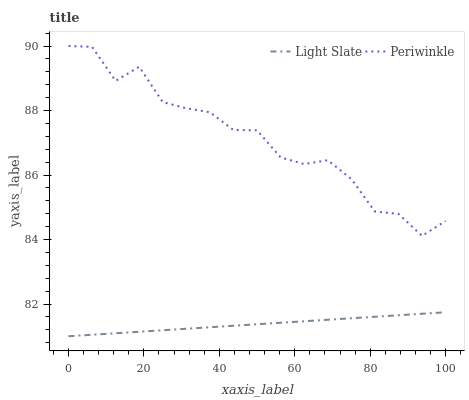Does Light Slate have the minimum area under the curve?
Answer yes or no. Yes. Does Periwinkle have the maximum area under the curve?
Answer yes or no. Yes. Does Periwinkle have the minimum area under the curve?
Answer yes or no. No. Is Light Slate the smoothest?
Answer yes or no. Yes. Is Periwinkle the roughest?
Answer yes or no. Yes. Is Periwinkle the smoothest?
Answer yes or no. No. Does Light Slate have the lowest value?
Answer yes or no. Yes. Does Periwinkle have the lowest value?
Answer yes or no. No. Does Periwinkle have the highest value?
Answer yes or no. Yes. Is Light Slate less than Periwinkle?
Answer yes or no. Yes. Is Periwinkle greater than Light Slate?
Answer yes or no. Yes. Does Light Slate intersect Periwinkle?
Answer yes or no. No. 